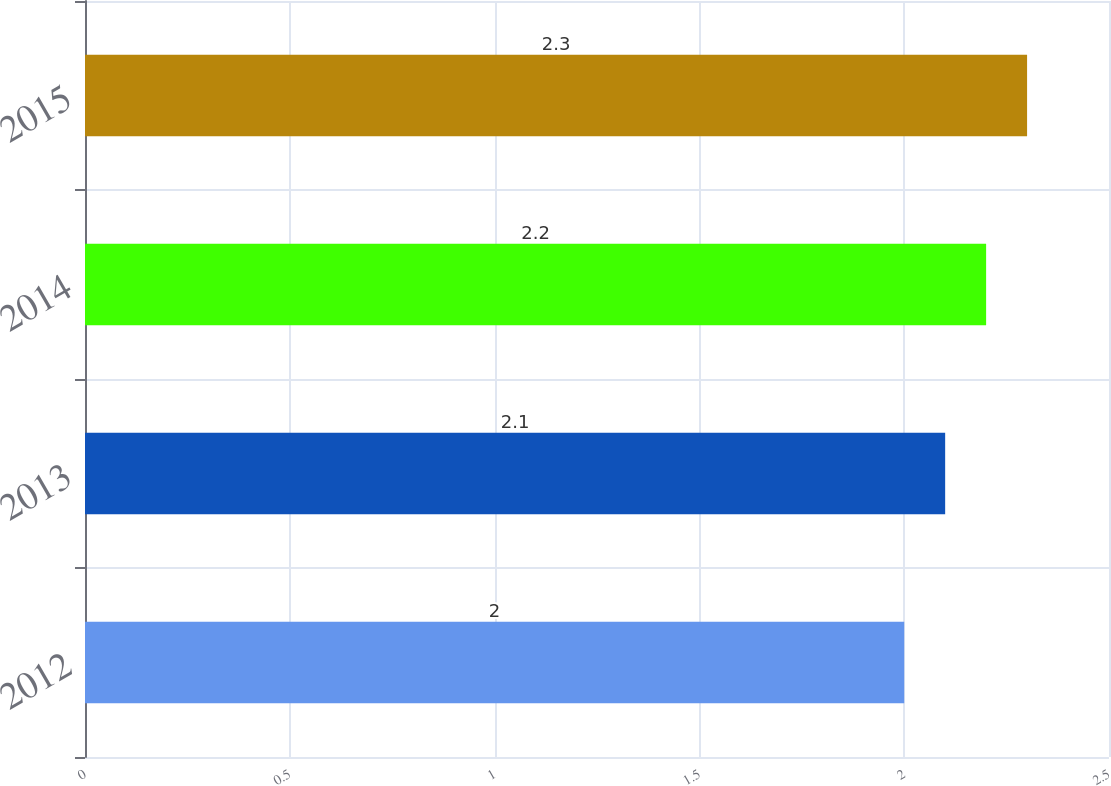Convert chart to OTSL. <chart><loc_0><loc_0><loc_500><loc_500><bar_chart><fcel>2012<fcel>2013<fcel>2014<fcel>2015<nl><fcel>2<fcel>2.1<fcel>2.2<fcel>2.3<nl></chart> 